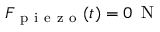<formula> <loc_0><loc_0><loc_500><loc_500>F _ { p i e z o } ( t ) = 0 \, N</formula> 